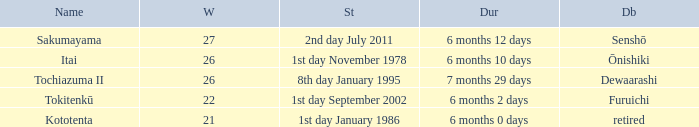Which Start has a Duration of 6 months 2 days? 1st day September 2002. 